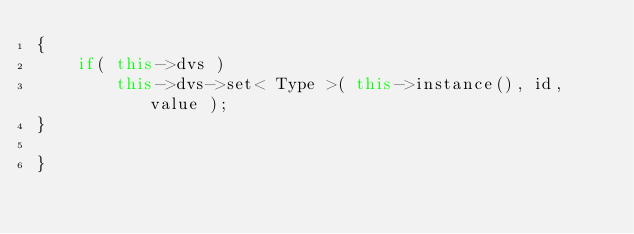Convert code to text. <code><loc_0><loc_0><loc_500><loc_500><_C++_>{
    if( this->dvs )
        this->dvs->set< Type >( this->instance(), id, value );
}

}
</code> 